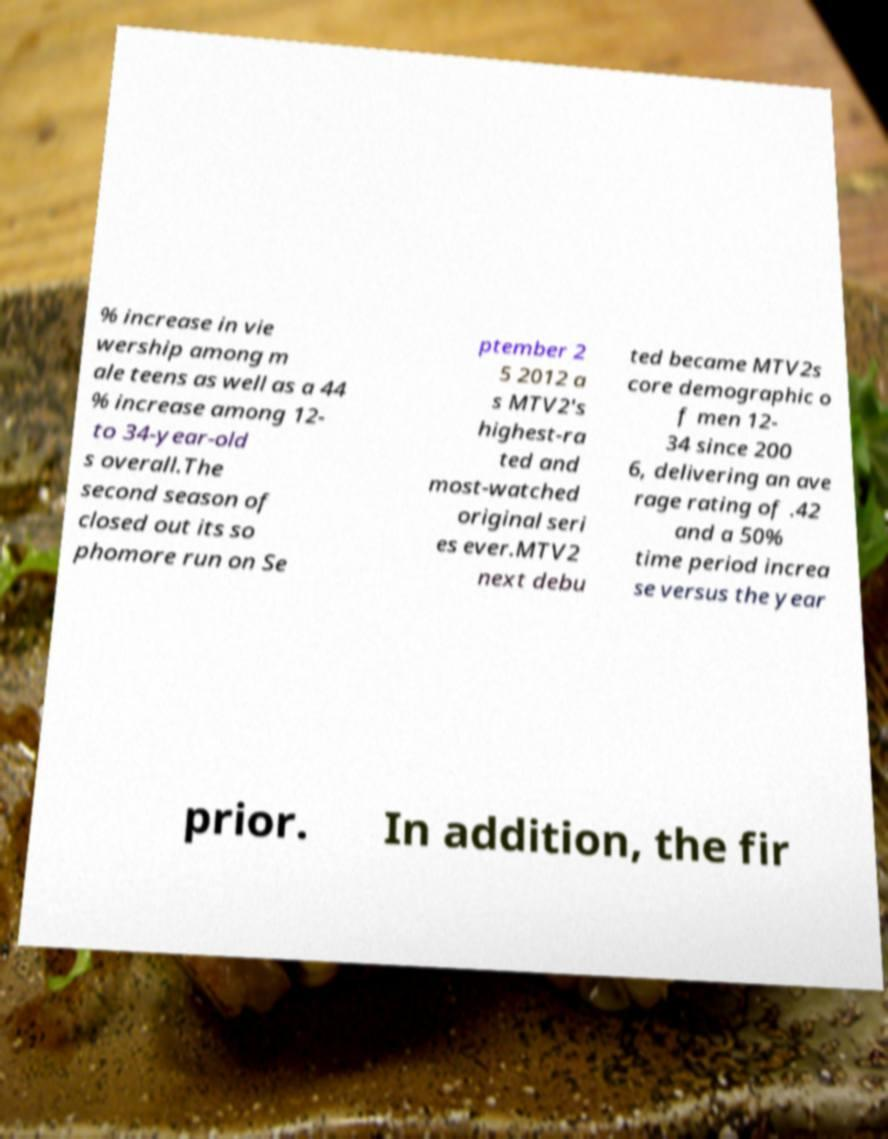Can you read and provide the text displayed in the image?This photo seems to have some interesting text. Can you extract and type it out for me? % increase in vie wership among m ale teens as well as a 44 % increase among 12- to 34-year-old s overall.The second season of closed out its so phomore run on Se ptember 2 5 2012 a s MTV2's highest-ra ted and most-watched original seri es ever.MTV2 next debu ted became MTV2s core demographic o f men 12- 34 since 200 6, delivering an ave rage rating of .42 and a 50% time period increa se versus the year prior. In addition, the fir 